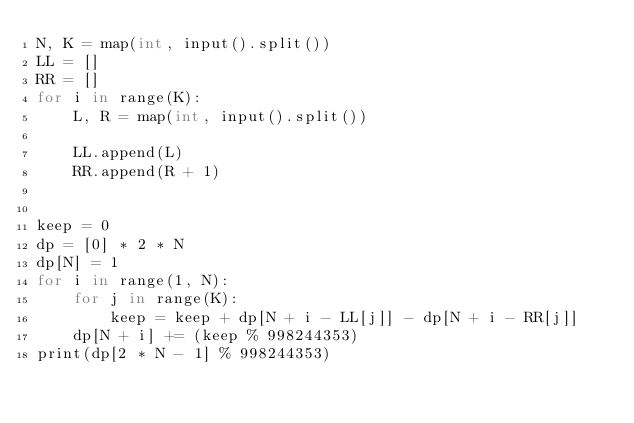<code> <loc_0><loc_0><loc_500><loc_500><_Cython_>N, K = map(int, input().split())
LL = []
RR = []
for i in range(K):
    L, R = map(int, input().split())

    LL.append(L)
    RR.append(R + 1)


keep = 0
dp = [0] * 2 * N
dp[N] = 1
for i in range(1, N):
    for j in range(K):
        keep = keep + dp[N + i - LL[j]] - dp[N + i - RR[j]]
    dp[N + i] += (keep % 998244353)
print(dp[2 * N - 1] % 998244353)
</code> 